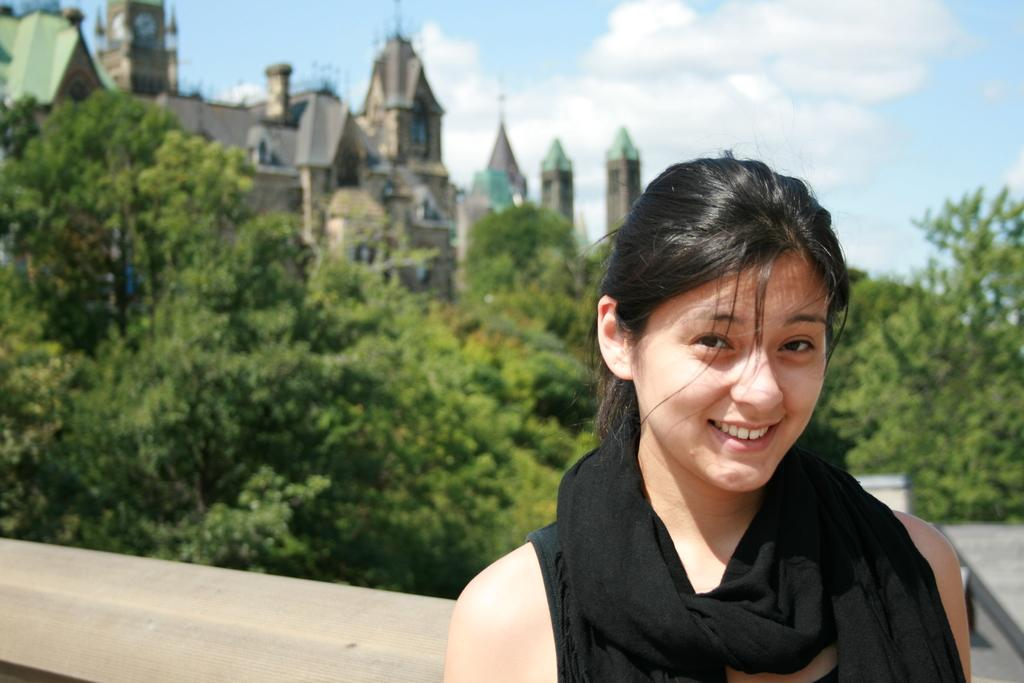Who is present in the image? There is a woman in the image. What is the woman doing in the image? The woman is standing and smiling. What can be seen behind the woman in the image? There are trees and buildings behind the woman. What part of the natural environment is visible in the image? The sky is visible in the image. What type of square can be seen in the image? There is no square present in the image. What kind of fruit is the woman holding in the image? The woman is not holding any fruit in the image. 